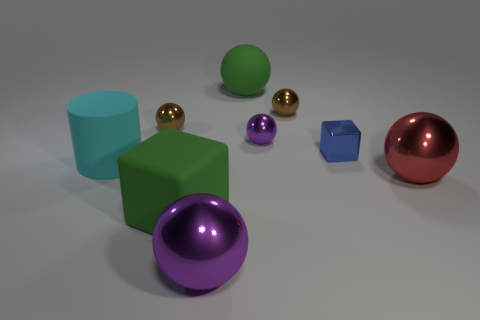Is there any other thing that has the same shape as the large purple thing?
Ensure brevity in your answer.  Yes. What number of objects are purple balls that are behind the matte cylinder or large objects?
Offer a very short reply. 6. Do the red metal object and the big purple thing have the same shape?
Your answer should be compact. Yes. What number of other objects are the same size as the blue metallic object?
Your answer should be very brief. 3. What is the color of the large rubber cube?
Ensure brevity in your answer.  Green. How many small objects are brown spheres or rubber cylinders?
Offer a very short reply. 2. Do the purple sphere that is in front of the red ball and the blue cube that is in front of the tiny purple thing have the same size?
Make the answer very short. No. There is a green matte object that is the same shape as the large red shiny object; what is its size?
Give a very brief answer. Large. Are there more cylinders that are to the right of the cyan object than large purple spheres right of the big block?
Provide a succinct answer. No. What material is the ball that is both right of the large rubber sphere and in front of the large cyan rubber cylinder?
Provide a short and direct response. Metal. 